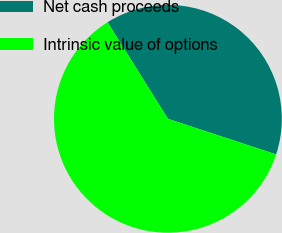Convert chart to OTSL. <chart><loc_0><loc_0><loc_500><loc_500><pie_chart><fcel>Net cash proceeds<fcel>Intrinsic value of options<nl><fcel>38.95%<fcel>61.05%<nl></chart> 